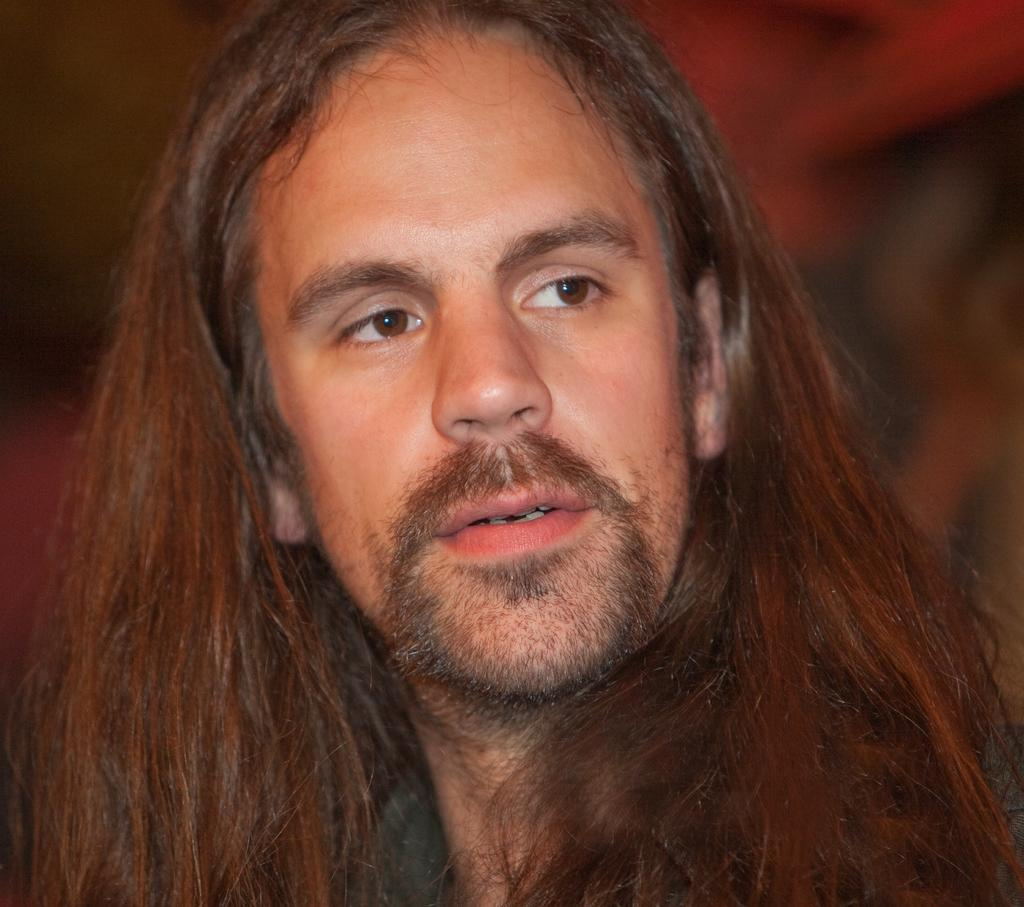What is the main subject of the image? There is a man in the image. Can you describe the man's appearance? The man has long hair. What is the condition of the place where the man is standing in the image? The provided facts do not mention any details about the place where the man is standing, so we cannot determine the condition of the place. 